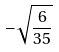Convert formula to latex. <formula><loc_0><loc_0><loc_500><loc_500>- \sqrt { \frac { 6 } { 3 5 } }</formula> 